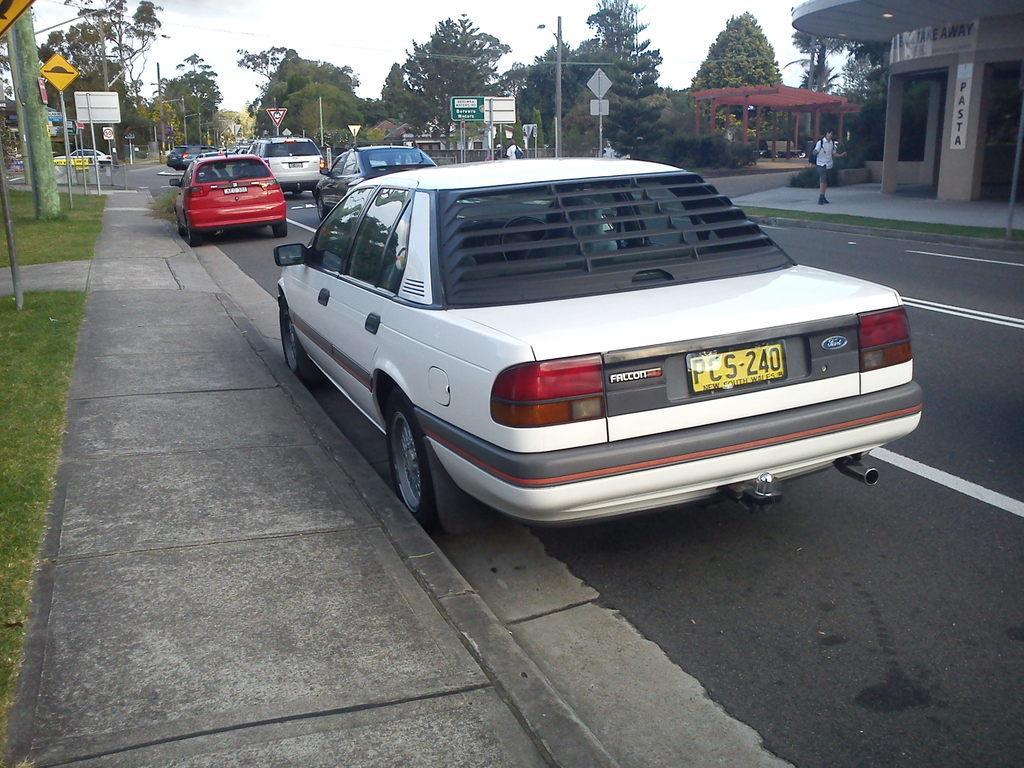Please provide a concise description of this image. In this image, we can see some trees and cars. There is a road in between poles and sign boards. There is a person standing in front of the building. There is a sky at the top of the image. 